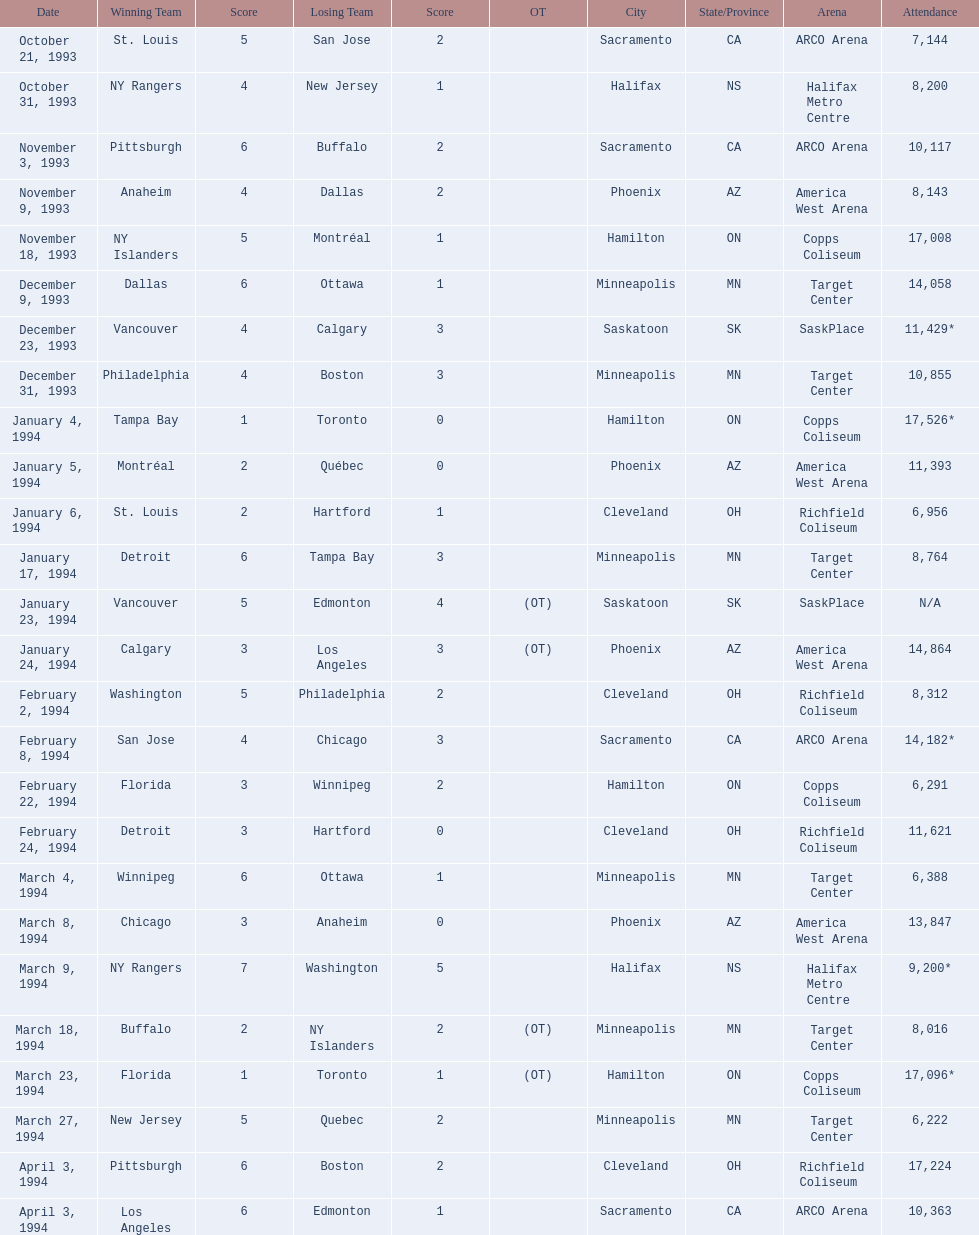What are the attendance figures for the 1993-94 nhl season? 7,144, 8,200, 10,117, 8,143, 17,008, 14,058, 11,429*, 10,855, 17,526*, 11,393, 6,956, 8,764, N/A, 14,864, 8,312, 14,182*, 6,291, 11,621, 6,388, 13,847, 9,200*, 8,016, 17,096*, 6,222, 17,224, 10,363. Which of these boasts the highest attendance? 17,526*. On what date did this attendance transpire? January 4, 1994. 